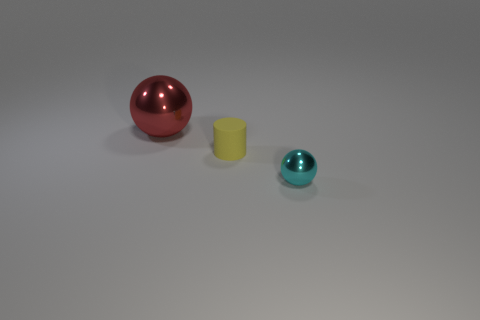Can you describe the placement of the objects in relation to each other? In the image, there are three objects arranged from left to right in the following order: a red spherical object, a small yellow cylinder, and a tiny cyan spherical ball. The cyan ball is the farthest to the right and is the smallest object, whereas the red sphere is the largest and is located on the left side. 